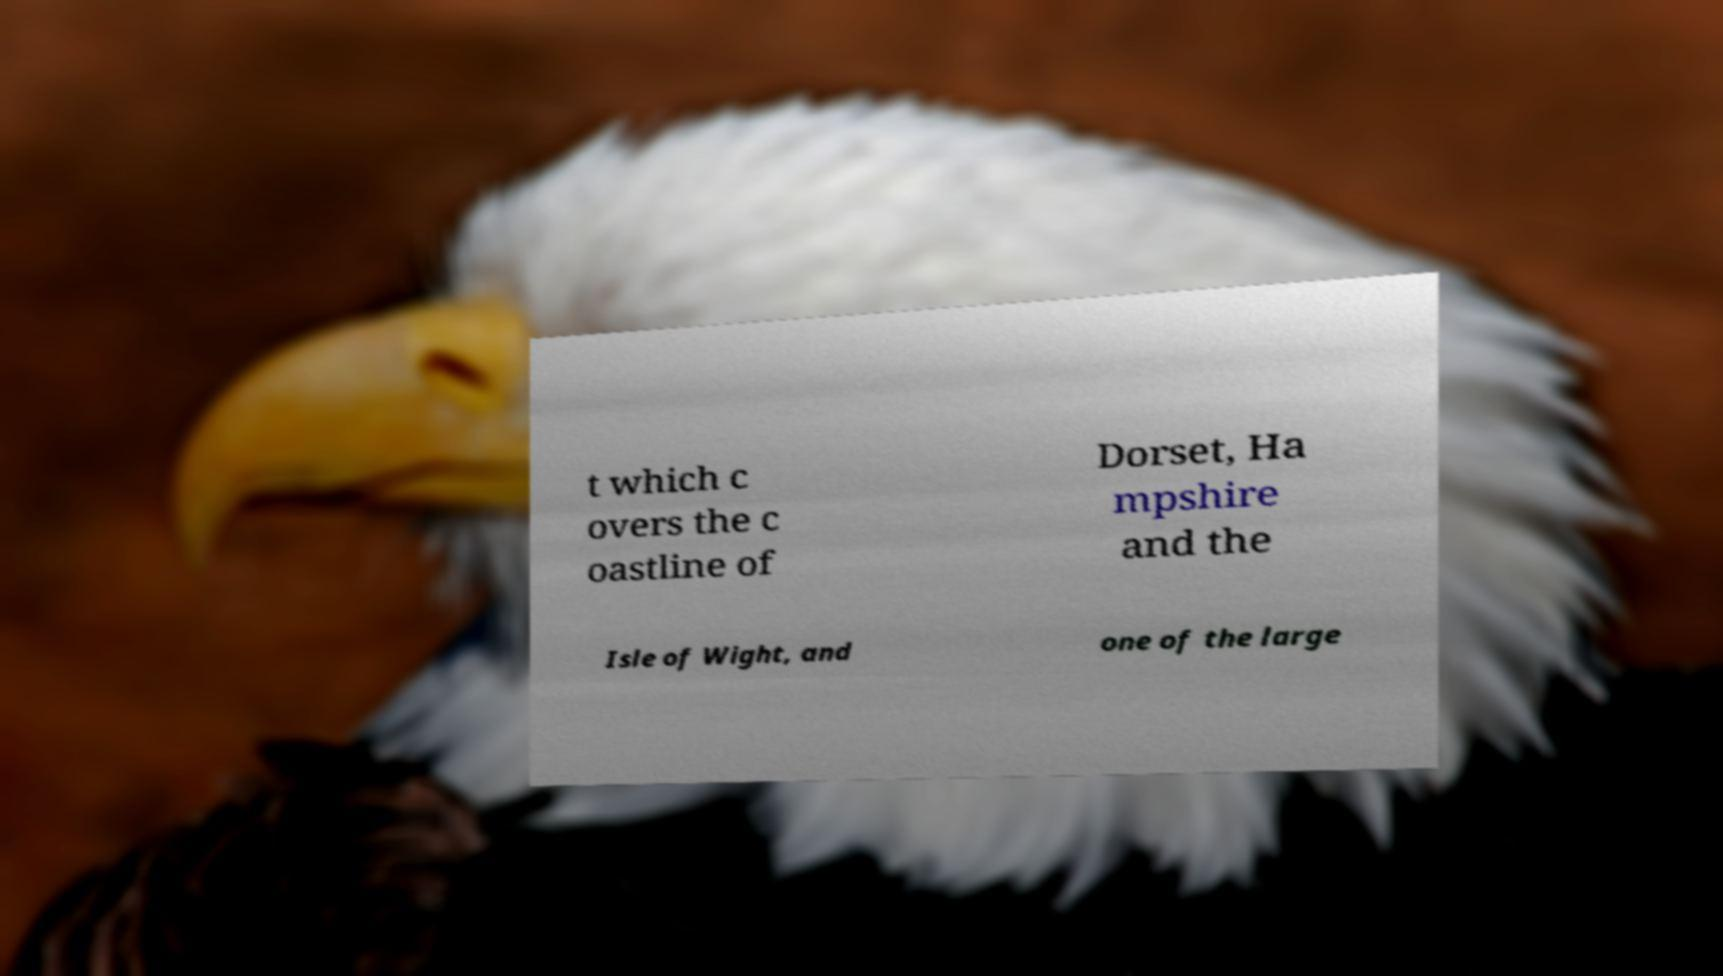Please read and relay the text visible in this image. What does it say? t which c overs the c oastline of Dorset, Ha mpshire and the Isle of Wight, and one of the large 